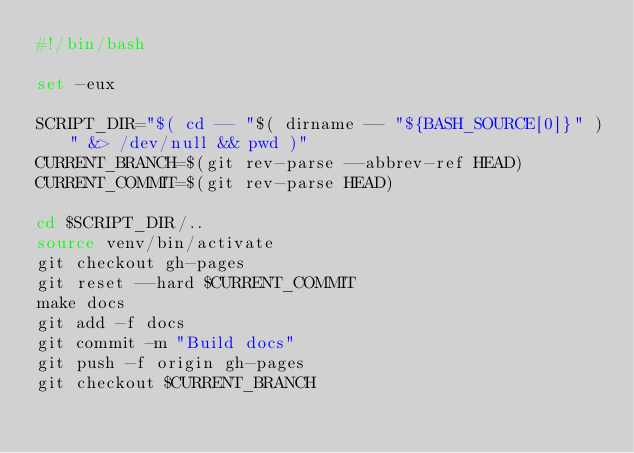Convert code to text. <code><loc_0><loc_0><loc_500><loc_500><_Bash_>#!/bin/bash

set -eux

SCRIPT_DIR="$( cd -- "$( dirname -- "${BASH_SOURCE[0]}" )" &> /dev/null && pwd )"
CURRENT_BRANCH=$(git rev-parse --abbrev-ref HEAD)
CURRENT_COMMIT=$(git rev-parse HEAD)

cd $SCRIPT_DIR/..
source venv/bin/activate
git checkout gh-pages
git reset --hard $CURRENT_COMMIT
make docs
git add -f docs
git commit -m "Build docs"
git push -f origin gh-pages
git checkout $CURRENT_BRANCH
</code> 